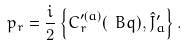Convert formula to latex. <formula><loc_0><loc_0><loc_500><loc_500>p _ { r } = \frac { i } 2 \left \{ C ^ { \prime ( a ) } _ { r } ( \ B q ) , \hat { J } _ { a } ^ { \prime } \right \} .</formula> 